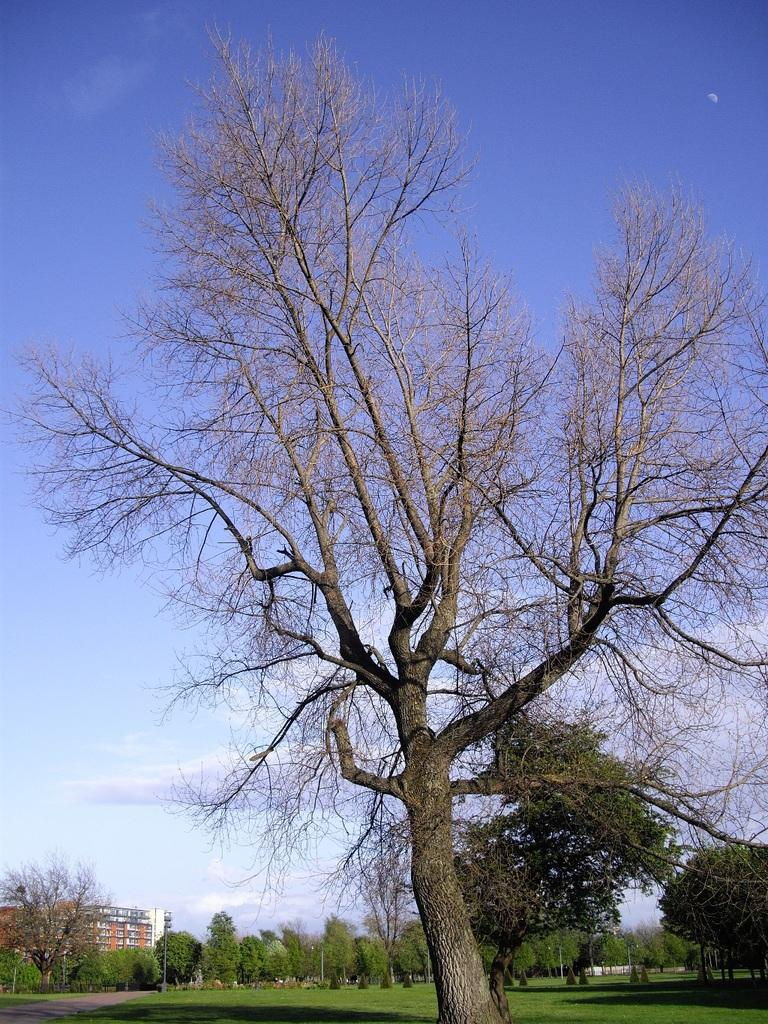What type of vegetation is visible in the image? There is grass in the image. What other natural elements can be seen in the image? There are trees in the image. What type of man-made structure is present in the image? There is a building in the image. What part of the natural environment is visible in the image? The sky is visible in the background of the image. Can you see any smoke coming from the building in the image? There is no smoke visible in the image. Is there a sidewalk present in the image? There is no sidewalk present in the image. 